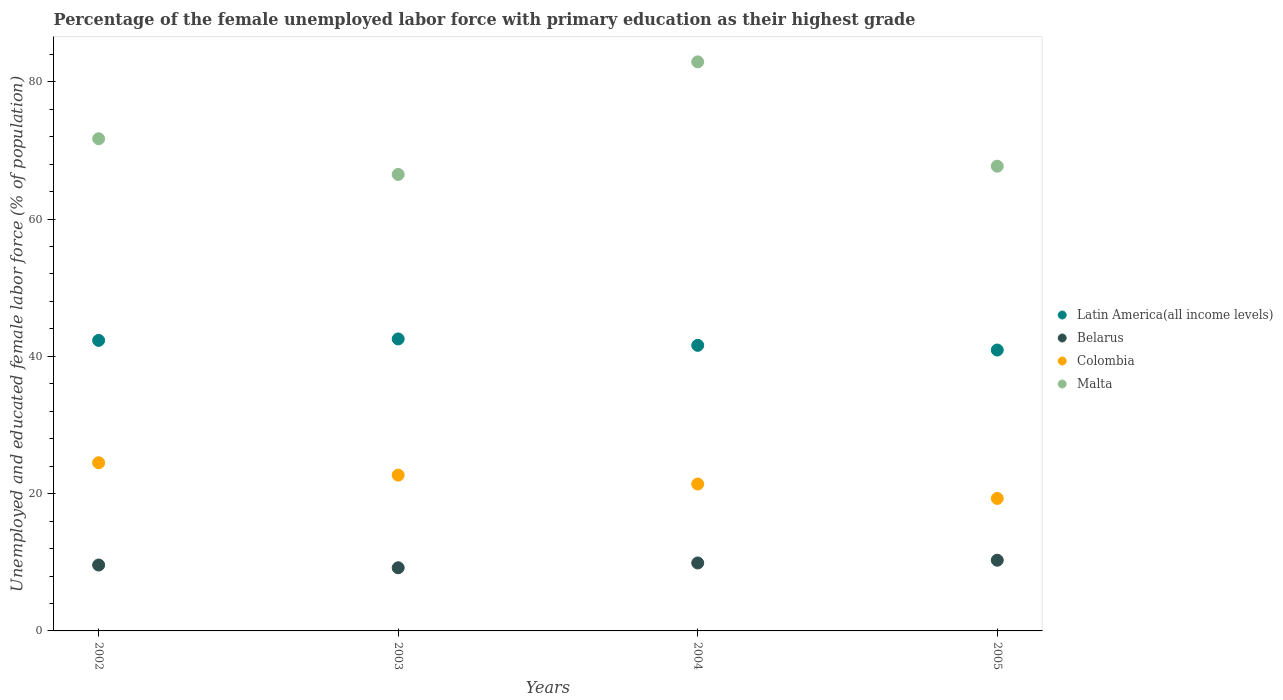How many different coloured dotlines are there?
Provide a short and direct response. 4. Is the number of dotlines equal to the number of legend labels?
Your response must be concise. Yes. What is the percentage of the unemployed female labor force with primary education in Colombia in 2005?
Keep it short and to the point. 19.3. Across all years, what is the maximum percentage of the unemployed female labor force with primary education in Latin America(all income levels)?
Make the answer very short. 42.54. Across all years, what is the minimum percentage of the unemployed female labor force with primary education in Latin America(all income levels)?
Offer a terse response. 40.92. What is the total percentage of the unemployed female labor force with primary education in Belarus in the graph?
Ensure brevity in your answer.  39. What is the difference between the percentage of the unemployed female labor force with primary education in Belarus in 2002 and that in 2005?
Ensure brevity in your answer.  -0.7. What is the difference between the percentage of the unemployed female labor force with primary education in Latin America(all income levels) in 2002 and the percentage of the unemployed female labor force with primary education in Malta in 2003?
Ensure brevity in your answer.  -24.18. What is the average percentage of the unemployed female labor force with primary education in Malta per year?
Your answer should be very brief. 72.2. In the year 2002, what is the difference between the percentage of the unemployed female labor force with primary education in Malta and percentage of the unemployed female labor force with primary education in Belarus?
Provide a succinct answer. 62.1. What is the ratio of the percentage of the unemployed female labor force with primary education in Malta in 2003 to that in 2005?
Make the answer very short. 0.98. What is the difference between the highest and the second highest percentage of the unemployed female labor force with primary education in Belarus?
Your response must be concise. 0.4. What is the difference between the highest and the lowest percentage of the unemployed female labor force with primary education in Belarus?
Your answer should be compact. 1.1. Is the sum of the percentage of the unemployed female labor force with primary education in Belarus in 2004 and 2005 greater than the maximum percentage of the unemployed female labor force with primary education in Colombia across all years?
Give a very brief answer. No. Is it the case that in every year, the sum of the percentage of the unemployed female labor force with primary education in Latin America(all income levels) and percentage of the unemployed female labor force with primary education in Colombia  is greater than the percentage of the unemployed female labor force with primary education in Belarus?
Provide a succinct answer. Yes. Does the percentage of the unemployed female labor force with primary education in Latin America(all income levels) monotonically increase over the years?
Provide a short and direct response. No. Is the percentage of the unemployed female labor force with primary education in Latin America(all income levels) strictly greater than the percentage of the unemployed female labor force with primary education in Colombia over the years?
Make the answer very short. Yes. How many dotlines are there?
Keep it short and to the point. 4. What is the difference between two consecutive major ticks on the Y-axis?
Give a very brief answer. 20. Does the graph contain grids?
Your answer should be very brief. No. How many legend labels are there?
Offer a very short reply. 4. What is the title of the graph?
Your answer should be compact. Percentage of the female unemployed labor force with primary education as their highest grade. Does "Korea (Democratic)" appear as one of the legend labels in the graph?
Provide a succinct answer. No. What is the label or title of the X-axis?
Your answer should be compact. Years. What is the label or title of the Y-axis?
Offer a terse response. Unemployed and educated female labor force (% of population). What is the Unemployed and educated female labor force (% of population) of Latin America(all income levels) in 2002?
Provide a short and direct response. 42.32. What is the Unemployed and educated female labor force (% of population) of Belarus in 2002?
Offer a very short reply. 9.6. What is the Unemployed and educated female labor force (% of population) of Malta in 2002?
Ensure brevity in your answer.  71.7. What is the Unemployed and educated female labor force (% of population) of Latin America(all income levels) in 2003?
Provide a succinct answer. 42.54. What is the Unemployed and educated female labor force (% of population) of Belarus in 2003?
Your response must be concise. 9.2. What is the Unemployed and educated female labor force (% of population) in Colombia in 2003?
Ensure brevity in your answer.  22.7. What is the Unemployed and educated female labor force (% of population) in Malta in 2003?
Provide a succinct answer. 66.5. What is the Unemployed and educated female labor force (% of population) in Latin America(all income levels) in 2004?
Provide a succinct answer. 41.6. What is the Unemployed and educated female labor force (% of population) in Belarus in 2004?
Your answer should be very brief. 9.9. What is the Unemployed and educated female labor force (% of population) in Colombia in 2004?
Give a very brief answer. 21.4. What is the Unemployed and educated female labor force (% of population) in Malta in 2004?
Make the answer very short. 82.9. What is the Unemployed and educated female labor force (% of population) in Latin America(all income levels) in 2005?
Ensure brevity in your answer.  40.92. What is the Unemployed and educated female labor force (% of population) of Belarus in 2005?
Your response must be concise. 10.3. What is the Unemployed and educated female labor force (% of population) in Colombia in 2005?
Keep it short and to the point. 19.3. What is the Unemployed and educated female labor force (% of population) in Malta in 2005?
Offer a terse response. 67.7. Across all years, what is the maximum Unemployed and educated female labor force (% of population) in Latin America(all income levels)?
Provide a short and direct response. 42.54. Across all years, what is the maximum Unemployed and educated female labor force (% of population) of Belarus?
Your response must be concise. 10.3. Across all years, what is the maximum Unemployed and educated female labor force (% of population) in Malta?
Provide a short and direct response. 82.9. Across all years, what is the minimum Unemployed and educated female labor force (% of population) in Latin America(all income levels)?
Provide a succinct answer. 40.92. Across all years, what is the minimum Unemployed and educated female labor force (% of population) in Belarus?
Make the answer very short. 9.2. Across all years, what is the minimum Unemployed and educated female labor force (% of population) of Colombia?
Keep it short and to the point. 19.3. Across all years, what is the minimum Unemployed and educated female labor force (% of population) of Malta?
Offer a terse response. 66.5. What is the total Unemployed and educated female labor force (% of population) in Latin America(all income levels) in the graph?
Offer a terse response. 167.38. What is the total Unemployed and educated female labor force (% of population) in Belarus in the graph?
Offer a terse response. 39. What is the total Unemployed and educated female labor force (% of population) in Colombia in the graph?
Provide a short and direct response. 87.9. What is the total Unemployed and educated female labor force (% of population) in Malta in the graph?
Your answer should be compact. 288.8. What is the difference between the Unemployed and educated female labor force (% of population) in Latin America(all income levels) in 2002 and that in 2003?
Provide a succinct answer. -0.21. What is the difference between the Unemployed and educated female labor force (% of population) in Malta in 2002 and that in 2003?
Your answer should be compact. 5.2. What is the difference between the Unemployed and educated female labor force (% of population) in Latin America(all income levels) in 2002 and that in 2004?
Offer a very short reply. 0.72. What is the difference between the Unemployed and educated female labor force (% of population) in Colombia in 2002 and that in 2004?
Give a very brief answer. 3.1. What is the difference between the Unemployed and educated female labor force (% of population) in Malta in 2002 and that in 2004?
Provide a short and direct response. -11.2. What is the difference between the Unemployed and educated female labor force (% of population) of Latin America(all income levels) in 2002 and that in 2005?
Offer a very short reply. 1.4. What is the difference between the Unemployed and educated female labor force (% of population) of Belarus in 2002 and that in 2005?
Ensure brevity in your answer.  -0.7. What is the difference between the Unemployed and educated female labor force (% of population) in Latin America(all income levels) in 2003 and that in 2004?
Give a very brief answer. 0.93. What is the difference between the Unemployed and educated female labor force (% of population) of Belarus in 2003 and that in 2004?
Keep it short and to the point. -0.7. What is the difference between the Unemployed and educated female labor force (% of population) of Malta in 2003 and that in 2004?
Provide a succinct answer. -16.4. What is the difference between the Unemployed and educated female labor force (% of population) in Latin America(all income levels) in 2003 and that in 2005?
Keep it short and to the point. 1.62. What is the difference between the Unemployed and educated female labor force (% of population) of Belarus in 2003 and that in 2005?
Provide a succinct answer. -1.1. What is the difference between the Unemployed and educated female labor force (% of population) in Latin America(all income levels) in 2004 and that in 2005?
Your response must be concise. 0.68. What is the difference between the Unemployed and educated female labor force (% of population) in Colombia in 2004 and that in 2005?
Offer a terse response. 2.1. What is the difference between the Unemployed and educated female labor force (% of population) in Latin America(all income levels) in 2002 and the Unemployed and educated female labor force (% of population) in Belarus in 2003?
Your response must be concise. 33.12. What is the difference between the Unemployed and educated female labor force (% of population) of Latin America(all income levels) in 2002 and the Unemployed and educated female labor force (% of population) of Colombia in 2003?
Make the answer very short. 19.62. What is the difference between the Unemployed and educated female labor force (% of population) in Latin America(all income levels) in 2002 and the Unemployed and educated female labor force (% of population) in Malta in 2003?
Your answer should be very brief. -24.18. What is the difference between the Unemployed and educated female labor force (% of population) of Belarus in 2002 and the Unemployed and educated female labor force (% of population) of Colombia in 2003?
Your response must be concise. -13.1. What is the difference between the Unemployed and educated female labor force (% of population) in Belarus in 2002 and the Unemployed and educated female labor force (% of population) in Malta in 2003?
Offer a terse response. -56.9. What is the difference between the Unemployed and educated female labor force (% of population) in Colombia in 2002 and the Unemployed and educated female labor force (% of population) in Malta in 2003?
Provide a succinct answer. -42. What is the difference between the Unemployed and educated female labor force (% of population) in Latin America(all income levels) in 2002 and the Unemployed and educated female labor force (% of population) in Belarus in 2004?
Offer a very short reply. 32.42. What is the difference between the Unemployed and educated female labor force (% of population) in Latin America(all income levels) in 2002 and the Unemployed and educated female labor force (% of population) in Colombia in 2004?
Your answer should be compact. 20.92. What is the difference between the Unemployed and educated female labor force (% of population) in Latin America(all income levels) in 2002 and the Unemployed and educated female labor force (% of population) in Malta in 2004?
Offer a terse response. -40.58. What is the difference between the Unemployed and educated female labor force (% of population) in Belarus in 2002 and the Unemployed and educated female labor force (% of population) in Colombia in 2004?
Make the answer very short. -11.8. What is the difference between the Unemployed and educated female labor force (% of population) in Belarus in 2002 and the Unemployed and educated female labor force (% of population) in Malta in 2004?
Provide a short and direct response. -73.3. What is the difference between the Unemployed and educated female labor force (% of population) of Colombia in 2002 and the Unemployed and educated female labor force (% of population) of Malta in 2004?
Your answer should be compact. -58.4. What is the difference between the Unemployed and educated female labor force (% of population) of Latin America(all income levels) in 2002 and the Unemployed and educated female labor force (% of population) of Belarus in 2005?
Your response must be concise. 32.02. What is the difference between the Unemployed and educated female labor force (% of population) in Latin America(all income levels) in 2002 and the Unemployed and educated female labor force (% of population) in Colombia in 2005?
Offer a terse response. 23.02. What is the difference between the Unemployed and educated female labor force (% of population) of Latin America(all income levels) in 2002 and the Unemployed and educated female labor force (% of population) of Malta in 2005?
Provide a succinct answer. -25.38. What is the difference between the Unemployed and educated female labor force (% of population) in Belarus in 2002 and the Unemployed and educated female labor force (% of population) in Colombia in 2005?
Provide a short and direct response. -9.7. What is the difference between the Unemployed and educated female labor force (% of population) in Belarus in 2002 and the Unemployed and educated female labor force (% of population) in Malta in 2005?
Offer a terse response. -58.1. What is the difference between the Unemployed and educated female labor force (% of population) in Colombia in 2002 and the Unemployed and educated female labor force (% of population) in Malta in 2005?
Make the answer very short. -43.2. What is the difference between the Unemployed and educated female labor force (% of population) in Latin America(all income levels) in 2003 and the Unemployed and educated female labor force (% of population) in Belarus in 2004?
Your response must be concise. 32.64. What is the difference between the Unemployed and educated female labor force (% of population) in Latin America(all income levels) in 2003 and the Unemployed and educated female labor force (% of population) in Colombia in 2004?
Give a very brief answer. 21.14. What is the difference between the Unemployed and educated female labor force (% of population) in Latin America(all income levels) in 2003 and the Unemployed and educated female labor force (% of population) in Malta in 2004?
Keep it short and to the point. -40.36. What is the difference between the Unemployed and educated female labor force (% of population) of Belarus in 2003 and the Unemployed and educated female labor force (% of population) of Colombia in 2004?
Your answer should be compact. -12.2. What is the difference between the Unemployed and educated female labor force (% of population) of Belarus in 2003 and the Unemployed and educated female labor force (% of population) of Malta in 2004?
Provide a succinct answer. -73.7. What is the difference between the Unemployed and educated female labor force (% of population) of Colombia in 2003 and the Unemployed and educated female labor force (% of population) of Malta in 2004?
Provide a short and direct response. -60.2. What is the difference between the Unemployed and educated female labor force (% of population) of Latin America(all income levels) in 2003 and the Unemployed and educated female labor force (% of population) of Belarus in 2005?
Keep it short and to the point. 32.24. What is the difference between the Unemployed and educated female labor force (% of population) of Latin America(all income levels) in 2003 and the Unemployed and educated female labor force (% of population) of Colombia in 2005?
Your answer should be very brief. 23.24. What is the difference between the Unemployed and educated female labor force (% of population) in Latin America(all income levels) in 2003 and the Unemployed and educated female labor force (% of population) in Malta in 2005?
Give a very brief answer. -25.16. What is the difference between the Unemployed and educated female labor force (% of population) of Belarus in 2003 and the Unemployed and educated female labor force (% of population) of Colombia in 2005?
Offer a terse response. -10.1. What is the difference between the Unemployed and educated female labor force (% of population) in Belarus in 2003 and the Unemployed and educated female labor force (% of population) in Malta in 2005?
Your answer should be compact. -58.5. What is the difference between the Unemployed and educated female labor force (% of population) of Colombia in 2003 and the Unemployed and educated female labor force (% of population) of Malta in 2005?
Provide a succinct answer. -45. What is the difference between the Unemployed and educated female labor force (% of population) in Latin America(all income levels) in 2004 and the Unemployed and educated female labor force (% of population) in Belarus in 2005?
Make the answer very short. 31.3. What is the difference between the Unemployed and educated female labor force (% of population) in Latin America(all income levels) in 2004 and the Unemployed and educated female labor force (% of population) in Colombia in 2005?
Make the answer very short. 22.3. What is the difference between the Unemployed and educated female labor force (% of population) in Latin America(all income levels) in 2004 and the Unemployed and educated female labor force (% of population) in Malta in 2005?
Provide a short and direct response. -26.1. What is the difference between the Unemployed and educated female labor force (% of population) in Belarus in 2004 and the Unemployed and educated female labor force (% of population) in Colombia in 2005?
Your answer should be compact. -9.4. What is the difference between the Unemployed and educated female labor force (% of population) in Belarus in 2004 and the Unemployed and educated female labor force (% of population) in Malta in 2005?
Your answer should be very brief. -57.8. What is the difference between the Unemployed and educated female labor force (% of population) of Colombia in 2004 and the Unemployed and educated female labor force (% of population) of Malta in 2005?
Keep it short and to the point. -46.3. What is the average Unemployed and educated female labor force (% of population) of Latin America(all income levels) per year?
Offer a terse response. 41.85. What is the average Unemployed and educated female labor force (% of population) in Belarus per year?
Offer a terse response. 9.75. What is the average Unemployed and educated female labor force (% of population) in Colombia per year?
Offer a very short reply. 21.98. What is the average Unemployed and educated female labor force (% of population) in Malta per year?
Offer a very short reply. 72.2. In the year 2002, what is the difference between the Unemployed and educated female labor force (% of population) of Latin America(all income levels) and Unemployed and educated female labor force (% of population) of Belarus?
Give a very brief answer. 32.72. In the year 2002, what is the difference between the Unemployed and educated female labor force (% of population) of Latin America(all income levels) and Unemployed and educated female labor force (% of population) of Colombia?
Keep it short and to the point. 17.82. In the year 2002, what is the difference between the Unemployed and educated female labor force (% of population) in Latin America(all income levels) and Unemployed and educated female labor force (% of population) in Malta?
Provide a succinct answer. -29.38. In the year 2002, what is the difference between the Unemployed and educated female labor force (% of population) in Belarus and Unemployed and educated female labor force (% of population) in Colombia?
Your answer should be very brief. -14.9. In the year 2002, what is the difference between the Unemployed and educated female labor force (% of population) in Belarus and Unemployed and educated female labor force (% of population) in Malta?
Your response must be concise. -62.1. In the year 2002, what is the difference between the Unemployed and educated female labor force (% of population) in Colombia and Unemployed and educated female labor force (% of population) in Malta?
Your response must be concise. -47.2. In the year 2003, what is the difference between the Unemployed and educated female labor force (% of population) of Latin America(all income levels) and Unemployed and educated female labor force (% of population) of Belarus?
Give a very brief answer. 33.34. In the year 2003, what is the difference between the Unemployed and educated female labor force (% of population) in Latin America(all income levels) and Unemployed and educated female labor force (% of population) in Colombia?
Provide a succinct answer. 19.84. In the year 2003, what is the difference between the Unemployed and educated female labor force (% of population) in Latin America(all income levels) and Unemployed and educated female labor force (% of population) in Malta?
Your answer should be very brief. -23.96. In the year 2003, what is the difference between the Unemployed and educated female labor force (% of population) of Belarus and Unemployed and educated female labor force (% of population) of Malta?
Your answer should be very brief. -57.3. In the year 2003, what is the difference between the Unemployed and educated female labor force (% of population) of Colombia and Unemployed and educated female labor force (% of population) of Malta?
Provide a succinct answer. -43.8. In the year 2004, what is the difference between the Unemployed and educated female labor force (% of population) of Latin America(all income levels) and Unemployed and educated female labor force (% of population) of Belarus?
Ensure brevity in your answer.  31.7. In the year 2004, what is the difference between the Unemployed and educated female labor force (% of population) of Latin America(all income levels) and Unemployed and educated female labor force (% of population) of Colombia?
Ensure brevity in your answer.  20.2. In the year 2004, what is the difference between the Unemployed and educated female labor force (% of population) in Latin America(all income levels) and Unemployed and educated female labor force (% of population) in Malta?
Offer a terse response. -41.3. In the year 2004, what is the difference between the Unemployed and educated female labor force (% of population) in Belarus and Unemployed and educated female labor force (% of population) in Malta?
Your answer should be very brief. -73. In the year 2004, what is the difference between the Unemployed and educated female labor force (% of population) of Colombia and Unemployed and educated female labor force (% of population) of Malta?
Give a very brief answer. -61.5. In the year 2005, what is the difference between the Unemployed and educated female labor force (% of population) of Latin America(all income levels) and Unemployed and educated female labor force (% of population) of Belarus?
Your answer should be very brief. 30.62. In the year 2005, what is the difference between the Unemployed and educated female labor force (% of population) of Latin America(all income levels) and Unemployed and educated female labor force (% of population) of Colombia?
Your answer should be compact. 21.62. In the year 2005, what is the difference between the Unemployed and educated female labor force (% of population) of Latin America(all income levels) and Unemployed and educated female labor force (% of population) of Malta?
Provide a short and direct response. -26.78. In the year 2005, what is the difference between the Unemployed and educated female labor force (% of population) of Belarus and Unemployed and educated female labor force (% of population) of Colombia?
Give a very brief answer. -9. In the year 2005, what is the difference between the Unemployed and educated female labor force (% of population) of Belarus and Unemployed and educated female labor force (% of population) of Malta?
Your response must be concise. -57.4. In the year 2005, what is the difference between the Unemployed and educated female labor force (% of population) in Colombia and Unemployed and educated female labor force (% of population) in Malta?
Your answer should be compact. -48.4. What is the ratio of the Unemployed and educated female labor force (% of population) in Latin America(all income levels) in 2002 to that in 2003?
Provide a short and direct response. 0.99. What is the ratio of the Unemployed and educated female labor force (% of population) in Belarus in 2002 to that in 2003?
Ensure brevity in your answer.  1.04. What is the ratio of the Unemployed and educated female labor force (% of population) of Colombia in 2002 to that in 2003?
Provide a short and direct response. 1.08. What is the ratio of the Unemployed and educated female labor force (% of population) in Malta in 2002 to that in 2003?
Your answer should be very brief. 1.08. What is the ratio of the Unemployed and educated female labor force (% of population) in Latin America(all income levels) in 2002 to that in 2004?
Your response must be concise. 1.02. What is the ratio of the Unemployed and educated female labor force (% of population) of Belarus in 2002 to that in 2004?
Offer a terse response. 0.97. What is the ratio of the Unemployed and educated female labor force (% of population) in Colombia in 2002 to that in 2004?
Give a very brief answer. 1.14. What is the ratio of the Unemployed and educated female labor force (% of population) of Malta in 2002 to that in 2004?
Provide a short and direct response. 0.86. What is the ratio of the Unemployed and educated female labor force (% of population) of Latin America(all income levels) in 2002 to that in 2005?
Your response must be concise. 1.03. What is the ratio of the Unemployed and educated female labor force (% of population) in Belarus in 2002 to that in 2005?
Provide a succinct answer. 0.93. What is the ratio of the Unemployed and educated female labor force (% of population) in Colombia in 2002 to that in 2005?
Provide a short and direct response. 1.27. What is the ratio of the Unemployed and educated female labor force (% of population) in Malta in 2002 to that in 2005?
Make the answer very short. 1.06. What is the ratio of the Unemployed and educated female labor force (% of population) of Latin America(all income levels) in 2003 to that in 2004?
Keep it short and to the point. 1.02. What is the ratio of the Unemployed and educated female labor force (% of population) of Belarus in 2003 to that in 2004?
Ensure brevity in your answer.  0.93. What is the ratio of the Unemployed and educated female labor force (% of population) in Colombia in 2003 to that in 2004?
Provide a succinct answer. 1.06. What is the ratio of the Unemployed and educated female labor force (% of population) in Malta in 2003 to that in 2004?
Your answer should be compact. 0.8. What is the ratio of the Unemployed and educated female labor force (% of population) of Latin America(all income levels) in 2003 to that in 2005?
Your answer should be very brief. 1.04. What is the ratio of the Unemployed and educated female labor force (% of population) of Belarus in 2003 to that in 2005?
Offer a very short reply. 0.89. What is the ratio of the Unemployed and educated female labor force (% of population) in Colombia in 2003 to that in 2005?
Keep it short and to the point. 1.18. What is the ratio of the Unemployed and educated female labor force (% of population) of Malta in 2003 to that in 2005?
Make the answer very short. 0.98. What is the ratio of the Unemployed and educated female labor force (% of population) in Latin America(all income levels) in 2004 to that in 2005?
Keep it short and to the point. 1.02. What is the ratio of the Unemployed and educated female labor force (% of population) of Belarus in 2004 to that in 2005?
Offer a terse response. 0.96. What is the ratio of the Unemployed and educated female labor force (% of population) in Colombia in 2004 to that in 2005?
Keep it short and to the point. 1.11. What is the ratio of the Unemployed and educated female labor force (% of population) of Malta in 2004 to that in 2005?
Ensure brevity in your answer.  1.22. What is the difference between the highest and the second highest Unemployed and educated female labor force (% of population) of Latin America(all income levels)?
Provide a succinct answer. 0.21. What is the difference between the highest and the second highest Unemployed and educated female labor force (% of population) in Colombia?
Make the answer very short. 1.8. What is the difference between the highest and the lowest Unemployed and educated female labor force (% of population) of Latin America(all income levels)?
Make the answer very short. 1.62. What is the difference between the highest and the lowest Unemployed and educated female labor force (% of population) in Malta?
Your answer should be very brief. 16.4. 